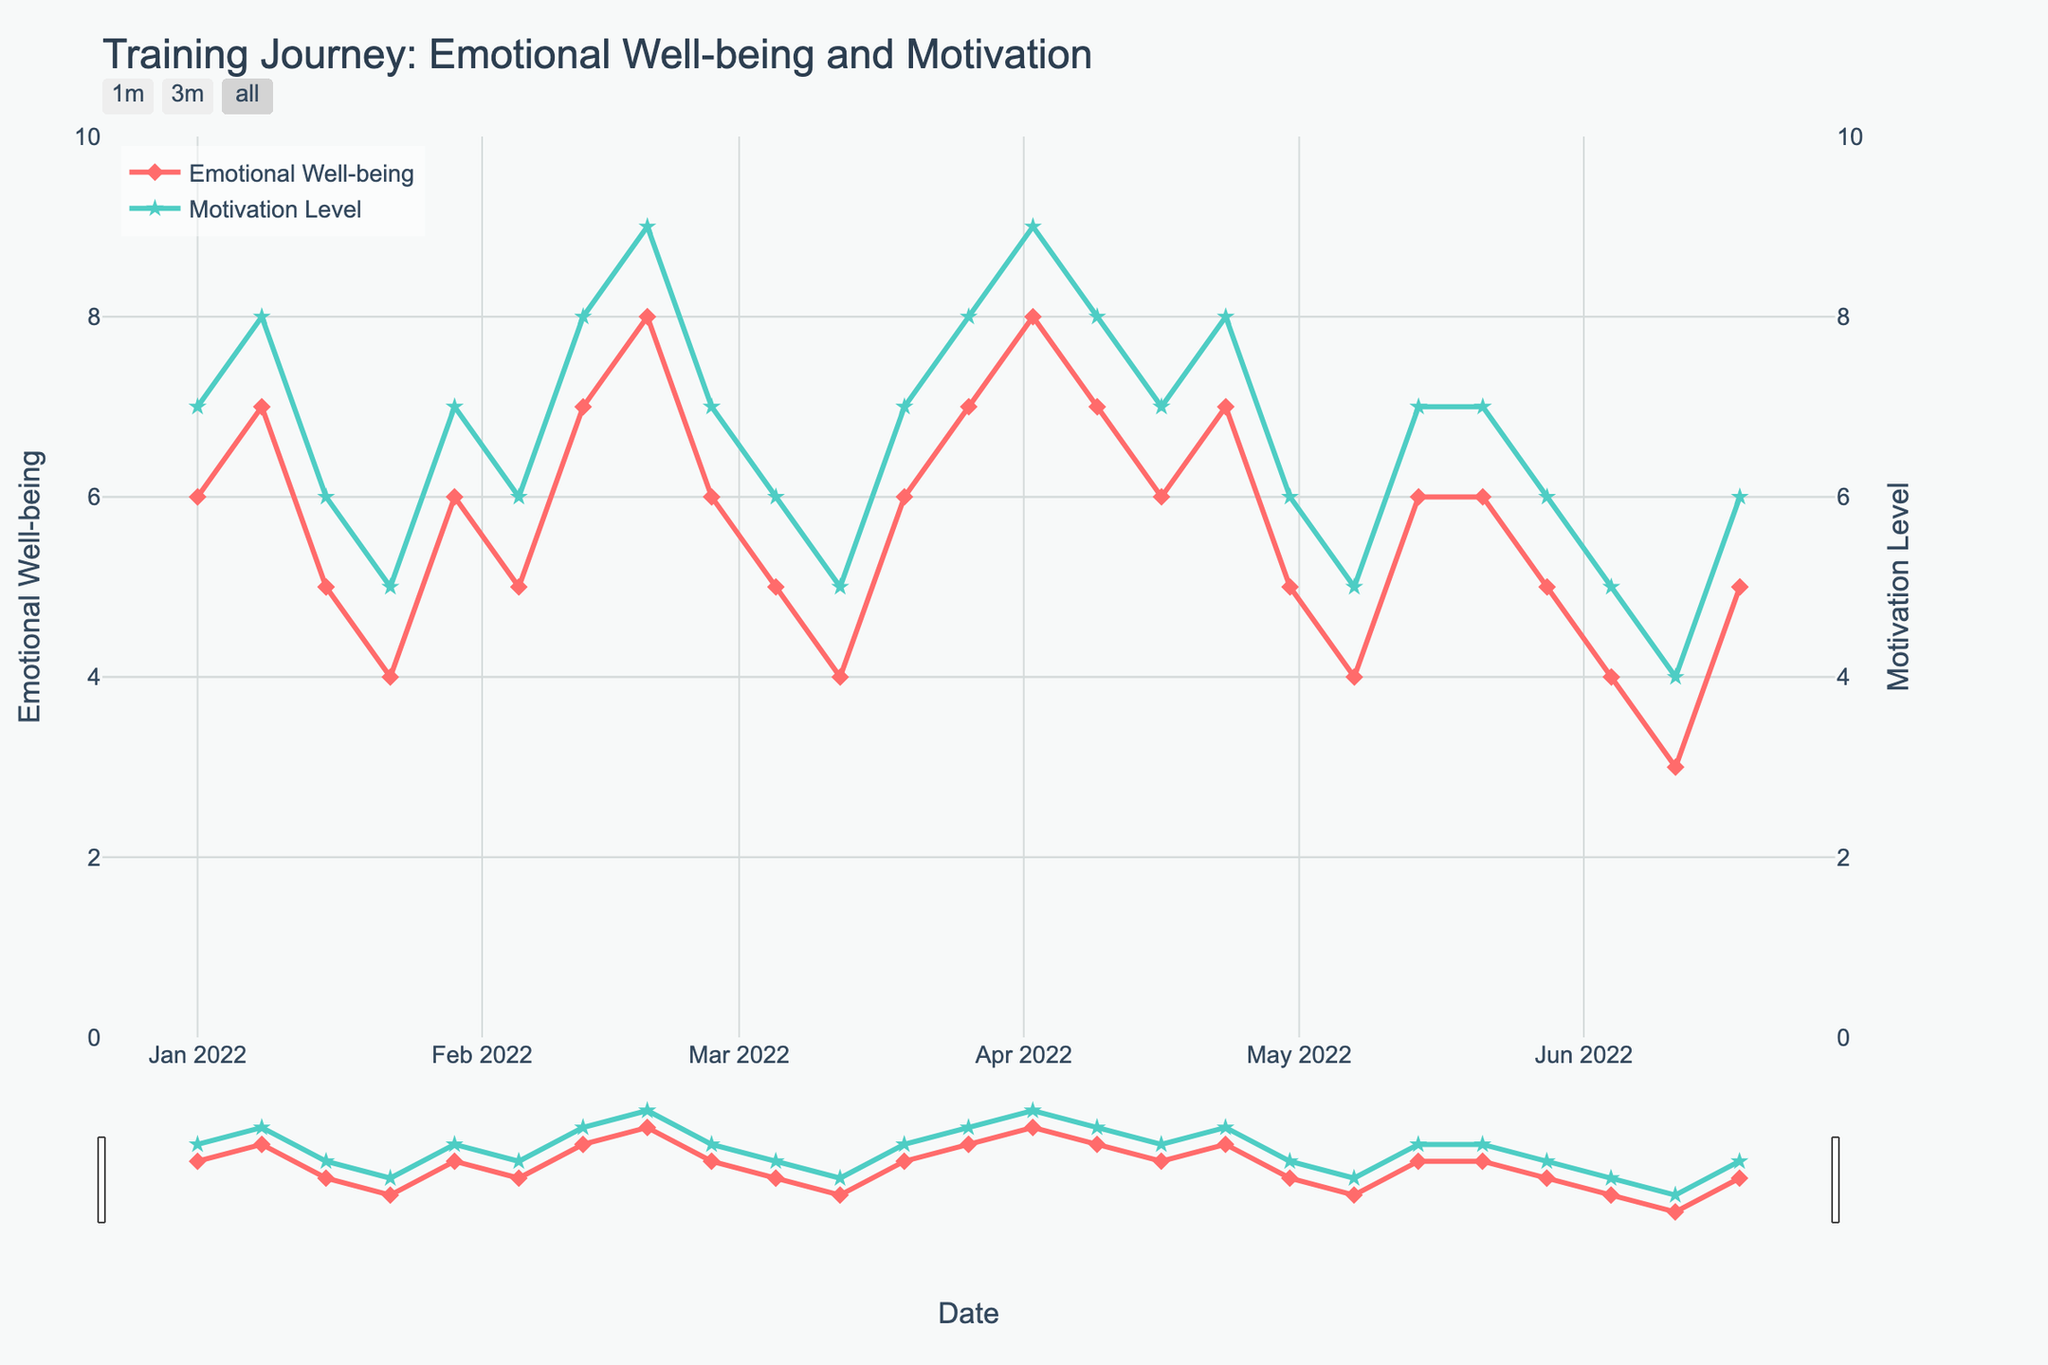What's the title of the figure? The title is usually displayed at the top of the figure, summarizing what the figure is about. Look at the top of the plot for the text.
Answer: Training Journey: Emotional Well-being and Motivation What are the two variables being plotted? The y-axes titles indicate which variables are being plotted. Check the y-axes on the left and right.
Answer: Emotional Well-being and Motivation Level What is the color of the Emotional Well-being line? The Emotional Well-being line is represented visually by a specific color. Identify the color of the line connected to Emotional Well-being.
Answer: Red How many times did Emotional Well-being drop to 4 or below? Identify the points where the Emotional Well-being value is 4 or less by tracing the line and markers closely. Count these instances.
Answer: 5 times On what date did Motivation Level peak at its highest value? Look for the star marker that reaches the highest point on the Motivation Level line and note the corresponding date on the x-axis.
Answer: 2022-02-19 and 2022-04-02 What's the difference between the highest and lowest Emotional Well-being values recorded? Identify the maximum and minimum values on the Emotional Well-being y-axis and calculate the difference.
Answer: 8 - 3 = 5 How did Motivation Level change from January to mid-February? Follow the green star line from January through mid-February, observing how the points rise or fall.
Answer: It generally increased Which period seems to have the most significant drop in Emotional Well-being? Look for the section where the red diamond line shows the steepest descent. Note the dates.
Answer: January 15 to January 22 How often did the Motivation Level match the Emotional Well-being value? Trace the points on both lines to see how often the values coincide. Count these matches.
Answer: 0 times Is there any period where Emotional Well-being and Motivation Level both trend upwards simultaneously? Observe both the red diamond and green star lines to find intervals where both lines are rising. Note the dates.
Answer: February 5 to February 19 